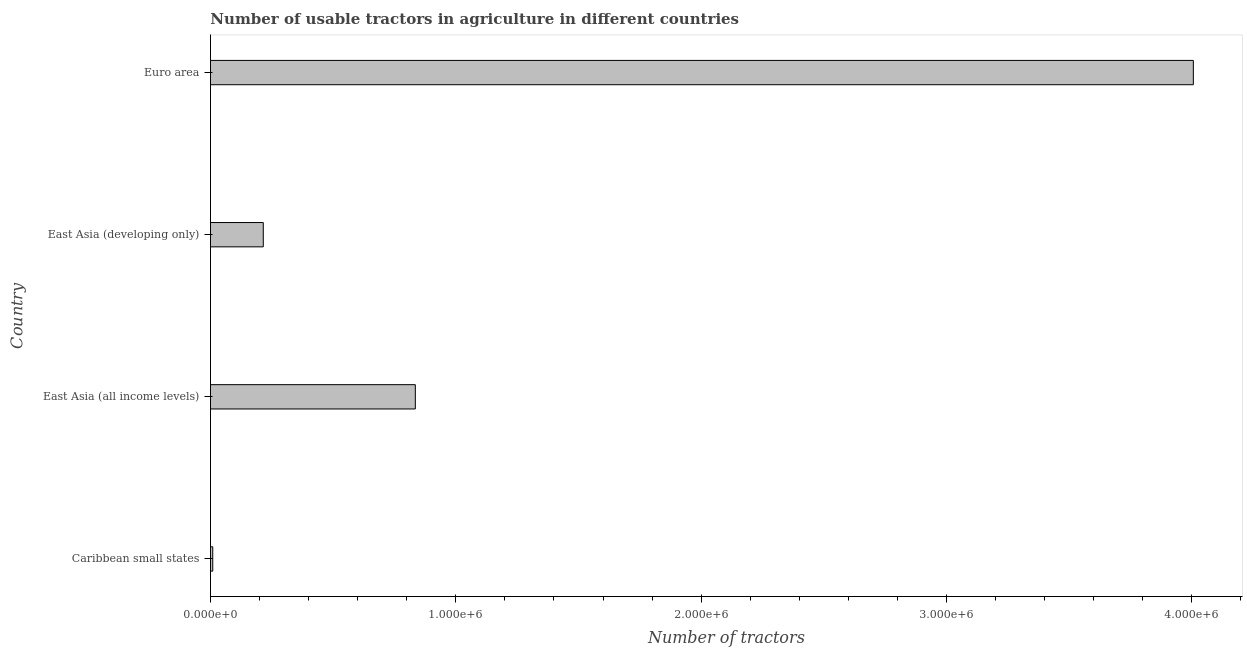What is the title of the graph?
Your response must be concise. Number of usable tractors in agriculture in different countries. What is the label or title of the X-axis?
Your answer should be very brief. Number of tractors. What is the number of tractors in Caribbean small states?
Your answer should be very brief. 9314. Across all countries, what is the maximum number of tractors?
Ensure brevity in your answer.  4.01e+06. Across all countries, what is the minimum number of tractors?
Your answer should be compact. 9314. In which country was the number of tractors minimum?
Provide a succinct answer. Caribbean small states. What is the sum of the number of tractors?
Keep it short and to the point. 5.07e+06. What is the difference between the number of tractors in East Asia (all income levels) and East Asia (developing only)?
Provide a succinct answer. 6.20e+05. What is the average number of tractors per country?
Offer a very short reply. 1.27e+06. What is the median number of tractors?
Provide a short and direct response. 5.25e+05. In how many countries, is the number of tractors greater than 1200000 ?
Offer a terse response. 1. What is the ratio of the number of tractors in Caribbean small states to that in East Asia (developing only)?
Your answer should be compact. 0.04. Is the difference between the number of tractors in Caribbean small states and Euro area greater than the difference between any two countries?
Make the answer very short. Yes. What is the difference between the highest and the second highest number of tractors?
Your answer should be very brief. 3.17e+06. Is the sum of the number of tractors in Caribbean small states and East Asia (all income levels) greater than the maximum number of tractors across all countries?
Offer a very short reply. No. What is the difference between the highest and the lowest number of tractors?
Provide a short and direct response. 4.00e+06. In how many countries, is the number of tractors greater than the average number of tractors taken over all countries?
Your answer should be compact. 1. How many bars are there?
Provide a short and direct response. 4. What is the difference between two consecutive major ticks on the X-axis?
Offer a very short reply. 1.00e+06. Are the values on the major ticks of X-axis written in scientific E-notation?
Your answer should be compact. Yes. What is the Number of tractors in Caribbean small states?
Keep it short and to the point. 9314. What is the Number of tractors of East Asia (all income levels)?
Your response must be concise. 8.35e+05. What is the Number of tractors of East Asia (developing only)?
Provide a succinct answer. 2.15e+05. What is the Number of tractors of Euro area?
Your answer should be compact. 4.01e+06. What is the difference between the Number of tractors in Caribbean small states and East Asia (all income levels)?
Give a very brief answer. -8.26e+05. What is the difference between the Number of tractors in Caribbean small states and East Asia (developing only)?
Your answer should be compact. -2.06e+05. What is the difference between the Number of tractors in Caribbean small states and Euro area?
Ensure brevity in your answer.  -4.00e+06. What is the difference between the Number of tractors in East Asia (all income levels) and East Asia (developing only)?
Offer a terse response. 6.20e+05. What is the difference between the Number of tractors in East Asia (all income levels) and Euro area?
Provide a succinct answer. -3.17e+06. What is the difference between the Number of tractors in East Asia (developing only) and Euro area?
Offer a terse response. -3.79e+06. What is the ratio of the Number of tractors in Caribbean small states to that in East Asia (all income levels)?
Make the answer very short. 0.01. What is the ratio of the Number of tractors in Caribbean small states to that in East Asia (developing only)?
Make the answer very short. 0.04. What is the ratio of the Number of tractors in Caribbean small states to that in Euro area?
Provide a succinct answer. 0. What is the ratio of the Number of tractors in East Asia (all income levels) to that in East Asia (developing only)?
Your response must be concise. 3.88. What is the ratio of the Number of tractors in East Asia (all income levels) to that in Euro area?
Provide a succinct answer. 0.21. What is the ratio of the Number of tractors in East Asia (developing only) to that in Euro area?
Offer a terse response. 0.05. 